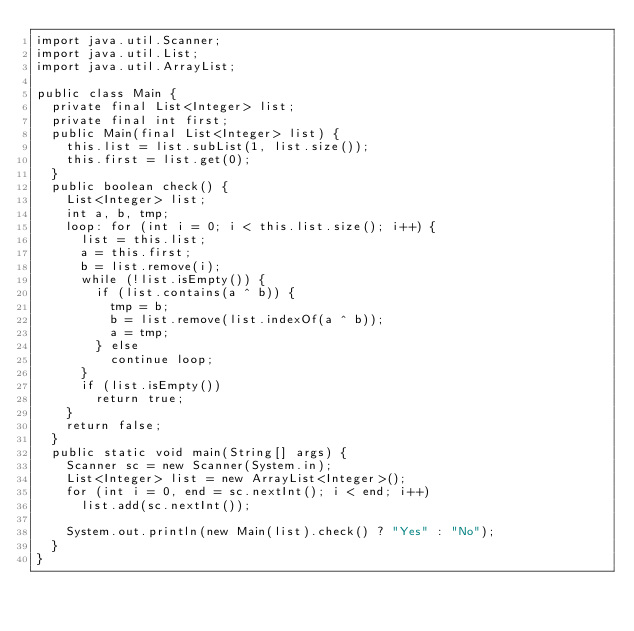Convert code to text. <code><loc_0><loc_0><loc_500><loc_500><_Java_>import java.util.Scanner;
import java.util.List;
import java.util.ArrayList;

public class Main {
  private final List<Integer> list;
  private final int first;
  public Main(final List<Integer> list) {
    this.list = list.subList(1, list.size());
    this.first = list.get(0);
  }
  public boolean check() {
    List<Integer> list;
    int a, b, tmp;
    loop: for (int i = 0; i < this.list.size(); i++) {
      list = this.list;
      a = this.first;
      b = list.remove(i);
      while (!list.isEmpty()) {
        if (list.contains(a ^ b)) {
          tmp = b;
          b = list.remove(list.indexOf(a ^ b));
          a = tmp;
        } else
          continue loop;
      }
      if (list.isEmpty())
        return true;
    }
    return false;
  }
  public static void main(String[] args) {
    Scanner sc = new Scanner(System.in);
    List<Integer> list = new ArrayList<Integer>();
    for (int i = 0, end = sc.nextInt(); i < end; i++)
      list.add(sc.nextInt());

    System.out.println(new Main(list).check() ? "Yes" : "No");
  }
}</code> 